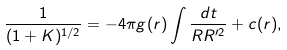Convert formula to latex. <formula><loc_0><loc_0><loc_500><loc_500>\frac { 1 } { ( 1 + K ) ^ { 1 / 2 } } = - 4 \pi g ( r ) \int { \frac { d t } { R R ^ { \prime 2 } } } + c ( r ) ,</formula> 